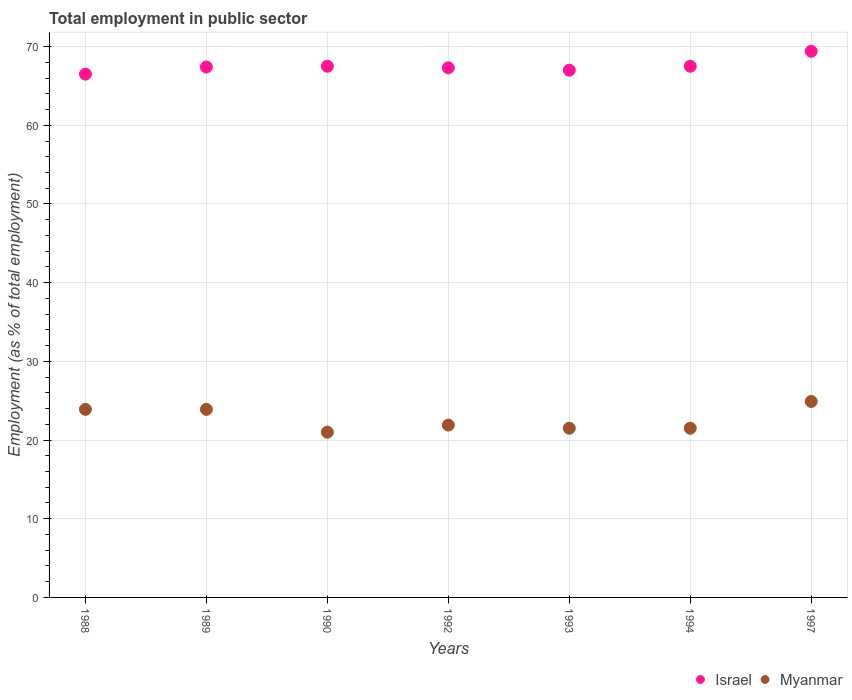How many different coloured dotlines are there?
Make the answer very short. 2. Is the number of dotlines equal to the number of legend labels?
Your answer should be compact. Yes. What is the employment in public sector in Myanmar in 1988?
Your answer should be compact. 23.9. Across all years, what is the maximum employment in public sector in Israel?
Offer a terse response. 69.4. In which year was the employment in public sector in Israel minimum?
Your response must be concise. 1988. What is the total employment in public sector in Israel in the graph?
Your response must be concise. 472.6. What is the difference between the employment in public sector in Myanmar in 1994 and that in 1997?
Ensure brevity in your answer.  -3.4. What is the difference between the employment in public sector in Myanmar in 1993 and the employment in public sector in Israel in 1988?
Your answer should be very brief. -45. What is the average employment in public sector in Myanmar per year?
Offer a very short reply. 22.66. In the year 1988, what is the difference between the employment in public sector in Israel and employment in public sector in Myanmar?
Provide a succinct answer. 42.6. What is the ratio of the employment in public sector in Israel in 1992 to that in 1993?
Provide a succinct answer. 1. Is the employment in public sector in Myanmar in 1992 less than that in 1994?
Your response must be concise. No. What is the difference between the highest and the second highest employment in public sector in Myanmar?
Make the answer very short. 1. What is the difference between the highest and the lowest employment in public sector in Myanmar?
Make the answer very short. 3.9. Is the sum of the employment in public sector in Israel in 1988 and 1990 greater than the maximum employment in public sector in Myanmar across all years?
Your answer should be very brief. Yes. Does the employment in public sector in Israel monotonically increase over the years?
Give a very brief answer. No. How many dotlines are there?
Offer a very short reply. 2. What is the difference between two consecutive major ticks on the Y-axis?
Ensure brevity in your answer.  10. Does the graph contain grids?
Your answer should be compact. Yes. How many legend labels are there?
Your response must be concise. 2. How are the legend labels stacked?
Give a very brief answer. Horizontal. What is the title of the graph?
Provide a short and direct response. Total employment in public sector. Does "Australia" appear as one of the legend labels in the graph?
Your answer should be very brief. No. What is the label or title of the Y-axis?
Your answer should be very brief. Employment (as % of total employment). What is the Employment (as % of total employment) in Israel in 1988?
Offer a terse response. 66.5. What is the Employment (as % of total employment) in Myanmar in 1988?
Provide a succinct answer. 23.9. What is the Employment (as % of total employment) of Israel in 1989?
Provide a succinct answer. 67.4. What is the Employment (as % of total employment) in Myanmar in 1989?
Offer a terse response. 23.9. What is the Employment (as % of total employment) of Israel in 1990?
Provide a short and direct response. 67.5. What is the Employment (as % of total employment) in Myanmar in 1990?
Offer a terse response. 21. What is the Employment (as % of total employment) in Israel in 1992?
Provide a succinct answer. 67.3. What is the Employment (as % of total employment) of Myanmar in 1992?
Ensure brevity in your answer.  21.9. What is the Employment (as % of total employment) of Israel in 1993?
Provide a short and direct response. 67. What is the Employment (as % of total employment) of Myanmar in 1993?
Your response must be concise. 21.5. What is the Employment (as % of total employment) of Israel in 1994?
Provide a short and direct response. 67.5. What is the Employment (as % of total employment) in Myanmar in 1994?
Ensure brevity in your answer.  21.5. What is the Employment (as % of total employment) in Israel in 1997?
Ensure brevity in your answer.  69.4. What is the Employment (as % of total employment) of Myanmar in 1997?
Provide a succinct answer. 24.9. Across all years, what is the maximum Employment (as % of total employment) of Israel?
Offer a very short reply. 69.4. Across all years, what is the maximum Employment (as % of total employment) of Myanmar?
Give a very brief answer. 24.9. Across all years, what is the minimum Employment (as % of total employment) in Israel?
Provide a succinct answer. 66.5. Across all years, what is the minimum Employment (as % of total employment) of Myanmar?
Your answer should be compact. 21. What is the total Employment (as % of total employment) in Israel in the graph?
Your response must be concise. 472.6. What is the total Employment (as % of total employment) of Myanmar in the graph?
Ensure brevity in your answer.  158.6. What is the difference between the Employment (as % of total employment) of Israel in 1988 and that in 1992?
Your response must be concise. -0.8. What is the difference between the Employment (as % of total employment) of Myanmar in 1988 and that in 1992?
Ensure brevity in your answer.  2. What is the difference between the Employment (as % of total employment) in Myanmar in 1988 and that in 1993?
Offer a very short reply. 2.4. What is the difference between the Employment (as % of total employment) in Myanmar in 1988 and that in 1994?
Your answer should be compact. 2.4. What is the difference between the Employment (as % of total employment) in Israel in 1988 and that in 1997?
Make the answer very short. -2.9. What is the difference between the Employment (as % of total employment) of Israel in 1989 and that in 1990?
Your answer should be very brief. -0.1. What is the difference between the Employment (as % of total employment) in Israel in 1989 and that in 1992?
Ensure brevity in your answer.  0.1. What is the difference between the Employment (as % of total employment) of Israel in 1989 and that in 1993?
Offer a terse response. 0.4. What is the difference between the Employment (as % of total employment) in Myanmar in 1989 and that in 1993?
Provide a succinct answer. 2.4. What is the difference between the Employment (as % of total employment) of Israel in 1989 and that in 1994?
Your response must be concise. -0.1. What is the difference between the Employment (as % of total employment) in Myanmar in 1989 and that in 1994?
Keep it short and to the point. 2.4. What is the difference between the Employment (as % of total employment) of Myanmar in 1989 and that in 1997?
Make the answer very short. -1. What is the difference between the Employment (as % of total employment) in Myanmar in 1990 and that in 1992?
Ensure brevity in your answer.  -0.9. What is the difference between the Employment (as % of total employment) in Myanmar in 1990 and that in 1993?
Provide a short and direct response. -0.5. What is the difference between the Employment (as % of total employment) in Israel in 1990 and that in 1997?
Your response must be concise. -1.9. What is the difference between the Employment (as % of total employment) of Myanmar in 1990 and that in 1997?
Ensure brevity in your answer.  -3.9. What is the difference between the Employment (as % of total employment) in Myanmar in 1992 and that in 1994?
Offer a terse response. 0.4. What is the difference between the Employment (as % of total employment) of Myanmar in 1992 and that in 1997?
Keep it short and to the point. -3. What is the difference between the Employment (as % of total employment) in Israel in 1994 and that in 1997?
Your response must be concise. -1.9. What is the difference between the Employment (as % of total employment) in Myanmar in 1994 and that in 1997?
Provide a short and direct response. -3.4. What is the difference between the Employment (as % of total employment) of Israel in 1988 and the Employment (as % of total employment) of Myanmar in 1989?
Keep it short and to the point. 42.6. What is the difference between the Employment (as % of total employment) in Israel in 1988 and the Employment (as % of total employment) in Myanmar in 1990?
Offer a very short reply. 45.5. What is the difference between the Employment (as % of total employment) of Israel in 1988 and the Employment (as % of total employment) of Myanmar in 1992?
Your answer should be compact. 44.6. What is the difference between the Employment (as % of total employment) in Israel in 1988 and the Employment (as % of total employment) in Myanmar in 1997?
Keep it short and to the point. 41.6. What is the difference between the Employment (as % of total employment) of Israel in 1989 and the Employment (as % of total employment) of Myanmar in 1990?
Ensure brevity in your answer.  46.4. What is the difference between the Employment (as % of total employment) of Israel in 1989 and the Employment (as % of total employment) of Myanmar in 1992?
Your answer should be compact. 45.5. What is the difference between the Employment (as % of total employment) in Israel in 1989 and the Employment (as % of total employment) in Myanmar in 1993?
Your answer should be very brief. 45.9. What is the difference between the Employment (as % of total employment) of Israel in 1989 and the Employment (as % of total employment) of Myanmar in 1994?
Your response must be concise. 45.9. What is the difference between the Employment (as % of total employment) of Israel in 1989 and the Employment (as % of total employment) of Myanmar in 1997?
Provide a short and direct response. 42.5. What is the difference between the Employment (as % of total employment) of Israel in 1990 and the Employment (as % of total employment) of Myanmar in 1992?
Provide a short and direct response. 45.6. What is the difference between the Employment (as % of total employment) of Israel in 1990 and the Employment (as % of total employment) of Myanmar in 1993?
Your response must be concise. 46. What is the difference between the Employment (as % of total employment) of Israel in 1990 and the Employment (as % of total employment) of Myanmar in 1997?
Your response must be concise. 42.6. What is the difference between the Employment (as % of total employment) of Israel in 1992 and the Employment (as % of total employment) of Myanmar in 1993?
Your response must be concise. 45.8. What is the difference between the Employment (as % of total employment) of Israel in 1992 and the Employment (as % of total employment) of Myanmar in 1994?
Make the answer very short. 45.8. What is the difference between the Employment (as % of total employment) in Israel in 1992 and the Employment (as % of total employment) in Myanmar in 1997?
Your answer should be very brief. 42.4. What is the difference between the Employment (as % of total employment) of Israel in 1993 and the Employment (as % of total employment) of Myanmar in 1994?
Give a very brief answer. 45.5. What is the difference between the Employment (as % of total employment) in Israel in 1993 and the Employment (as % of total employment) in Myanmar in 1997?
Give a very brief answer. 42.1. What is the difference between the Employment (as % of total employment) in Israel in 1994 and the Employment (as % of total employment) in Myanmar in 1997?
Ensure brevity in your answer.  42.6. What is the average Employment (as % of total employment) of Israel per year?
Provide a succinct answer. 67.51. What is the average Employment (as % of total employment) of Myanmar per year?
Offer a terse response. 22.66. In the year 1988, what is the difference between the Employment (as % of total employment) in Israel and Employment (as % of total employment) in Myanmar?
Ensure brevity in your answer.  42.6. In the year 1989, what is the difference between the Employment (as % of total employment) of Israel and Employment (as % of total employment) of Myanmar?
Provide a succinct answer. 43.5. In the year 1990, what is the difference between the Employment (as % of total employment) of Israel and Employment (as % of total employment) of Myanmar?
Your response must be concise. 46.5. In the year 1992, what is the difference between the Employment (as % of total employment) of Israel and Employment (as % of total employment) of Myanmar?
Offer a terse response. 45.4. In the year 1993, what is the difference between the Employment (as % of total employment) in Israel and Employment (as % of total employment) in Myanmar?
Your response must be concise. 45.5. In the year 1997, what is the difference between the Employment (as % of total employment) of Israel and Employment (as % of total employment) of Myanmar?
Your answer should be very brief. 44.5. What is the ratio of the Employment (as % of total employment) in Israel in 1988 to that in 1989?
Your answer should be compact. 0.99. What is the ratio of the Employment (as % of total employment) of Myanmar in 1988 to that in 1989?
Provide a short and direct response. 1. What is the ratio of the Employment (as % of total employment) of Israel in 1988 to that in 1990?
Make the answer very short. 0.99. What is the ratio of the Employment (as % of total employment) of Myanmar in 1988 to that in 1990?
Your answer should be compact. 1.14. What is the ratio of the Employment (as % of total employment) in Myanmar in 1988 to that in 1992?
Give a very brief answer. 1.09. What is the ratio of the Employment (as % of total employment) in Israel in 1988 to that in 1993?
Provide a short and direct response. 0.99. What is the ratio of the Employment (as % of total employment) of Myanmar in 1988 to that in 1993?
Ensure brevity in your answer.  1.11. What is the ratio of the Employment (as % of total employment) in Israel in 1988 to that in 1994?
Offer a terse response. 0.99. What is the ratio of the Employment (as % of total employment) of Myanmar in 1988 to that in 1994?
Provide a succinct answer. 1.11. What is the ratio of the Employment (as % of total employment) of Israel in 1988 to that in 1997?
Your answer should be very brief. 0.96. What is the ratio of the Employment (as % of total employment) in Myanmar in 1988 to that in 1997?
Make the answer very short. 0.96. What is the ratio of the Employment (as % of total employment) in Israel in 1989 to that in 1990?
Your response must be concise. 1. What is the ratio of the Employment (as % of total employment) in Myanmar in 1989 to that in 1990?
Keep it short and to the point. 1.14. What is the ratio of the Employment (as % of total employment) in Myanmar in 1989 to that in 1992?
Provide a short and direct response. 1.09. What is the ratio of the Employment (as % of total employment) in Israel in 1989 to that in 1993?
Ensure brevity in your answer.  1.01. What is the ratio of the Employment (as % of total employment) of Myanmar in 1989 to that in 1993?
Your answer should be compact. 1.11. What is the ratio of the Employment (as % of total employment) of Myanmar in 1989 to that in 1994?
Your answer should be compact. 1.11. What is the ratio of the Employment (as % of total employment) of Israel in 1989 to that in 1997?
Provide a succinct answer. 0.97. What is the ratio of the Employment (as % of total employment) in Myanmar in 1989 to that in 1997?
Provide a short and direct response. 0.96. What is the ratio of the Employment (as % of total employment) of Myanmar in 1990 to that in 1992?
Make the answer very short. 0.96. What is the ratio of the Employment (as % of total employment) in Israel in 1990 to that in 1993?
Provide a succinct answer. 1.01. What is the ratio of the Employment (as % of total employment) in Myanmar in 1990 to that in 1993?
Make the answer very short. 0.98. What is the ratio of the Employment (as % of total employment) in Myanmar in 1990 to that in 1994?
Your answer should be compact. 0.98. What is the ratio of the Employment (as % of total employment) of Israel in 1990 to that in 1997?
Your answer should be compact. 0.97. What is the ratio of the Employment (as % of total employment) in Myanmar in 1990 to that in 1997?
Your answer should be very brief. 0.84. What is the ratio of the Employment (as % of total employment) of Myanmar in 1992 to that in 1993?
Ensure brevity in your answer.  1.02. What is the ratio of the Employment (as % of total employment) in Myanmar in 1992 to that in 1994?
Provide a succinct answer. 1.02. What is the ratio of the Employment (as % of total employment) of Israel in 1992 to that in 1997?
Offer a terse response. 0.97. What is the ratio of the Employment (as % of total employment) in Myanmar in 1992 to that in 1997?
Your answer should be compact. 0.88. What is the ratio of the Employment (as % of total employment) in Israel in 1993 to that in 1994?
Give a very brief answer. 0.99. What is the ratio of the Employment (as % of total employment) in Myanmar in 1993 to that in 1994?
Give a very brief answer. 1. What is the ratio of the Employment (as % of total employment) in Israel in 1993 to that in 1997?
Keep it short and to the point. 0.97. What is the ratio of the Employment (as % of total employment) in Myanmar in 1993 to that in 1997?
Give a very brief answer. 0.86. What is the ratio of the Employment (as % of total employment) of Israel in 1994 to that in 1997?
Your answer should be very brief. 0.97. What is the ratio of the Employment (as % of total employment) of Myanmar in 1994 to that in 1997?
Your answer should be compact. 0.86. What is the difference between the highest and the second highest Employment (as % of total employment) in Myanmar?
Offer a terse response. 1. 